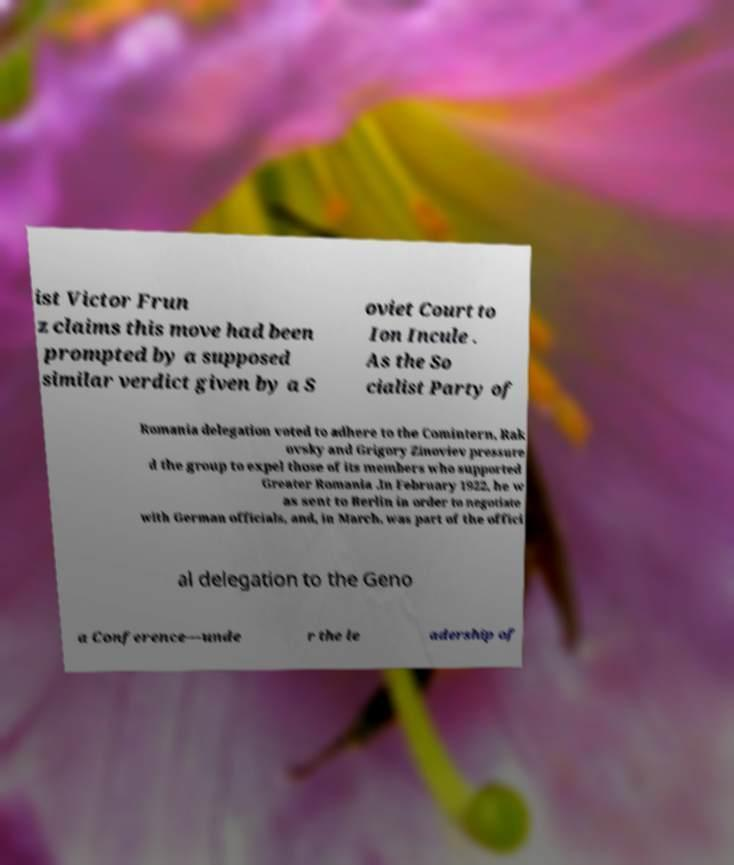There's text embedded in this image that I need extracted. Can you transcribe it verbatim? ist Victor Frun z claims this move had been prompted by a supposed similar verdict given by a S oviet Court to Ion Incule . As the So cialist Party of Romania delegation voted to adhere to the Comintern, Rak ovsky and Grigory Zinoviev pressure d the group to expel those of its members who supported Greater Romania .In February 1922, he w as sent to Berlin in order to negotiate with German officials, and, in March, was part of the offici al delegation to the Geno a Conference—unde r the le adership of 